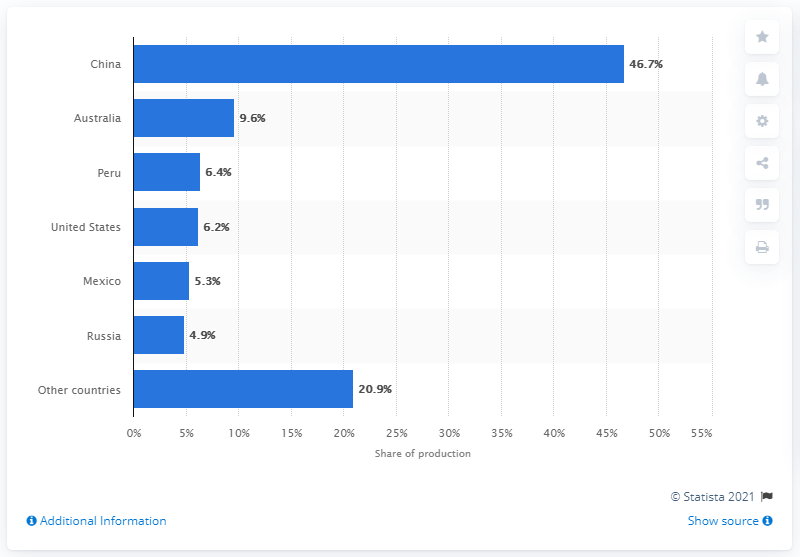Outline some significant characteristics in this image. In 2019, China produced 46.7% of the world's lead mine production. 